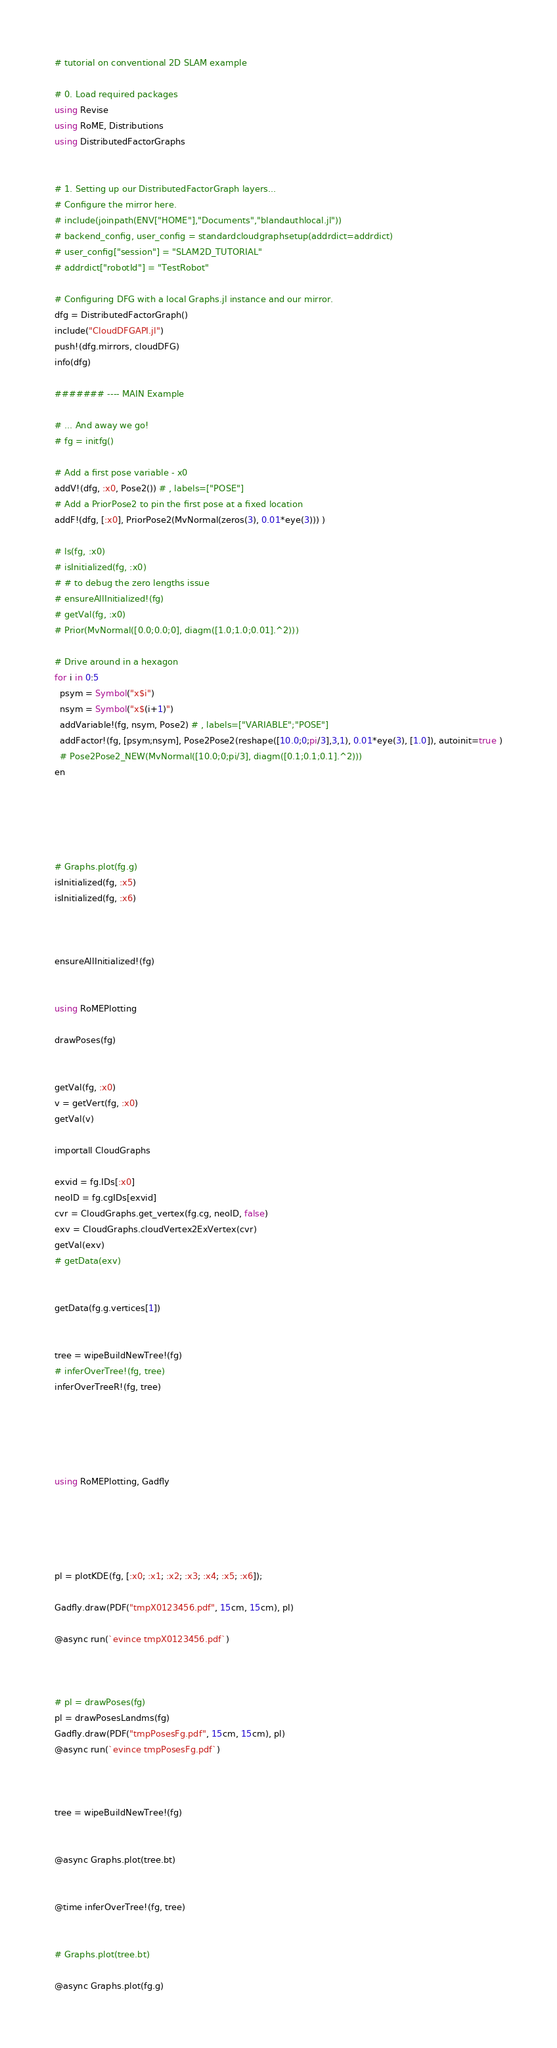Convert code to text. <code><loc_0><loc_0><loc_500><loc_500><_Julia_># tutorial on conventional 2D SLAM example

# 0. Load required packages
using Revise
using RoME, Distributions
using DistributedFactorGraphs


# 1. Setting up our DistributedFactorGraph layers...
# Configure the mirror here.
# include(joinpath(ENV["HOME"],"Documents","blandauthlocal.jl"))
# backend_config, user_config = standardcloudgraphsetup(addrdict=addrdict)
# user_config["session"] = "SLAM2D_TUTORIAL"
# addrdict["robotId"] = "TestRobot"

# Configuring DFG with a local Graphs.jl instance and our mirror.
dfg = DistributedFactorGraph()
include("CloudDFGAPI.jl")
push!(dfg.mirrors, cloudDFG)
info(dfg)

####### ---- MAIN Example

# ... And away we go!
# fg = initfg()

# Add a first pose variable - x0
addV!(dfg, :x0, Pose2()) # , labels=["POSE"]
# Add a PriorPose2 to pin the first pose at a fixed location
addF!(dfg, [:x0], PriorPose2(MvNormal(zeros(3), 0.01*eye(3))) )

# ls(fg, :x0)
# isInitialized(fg, :x0)
# # to debug the zero lengths issue
# ensureAllInitialized!(fg)
# getVal(fg, :x0)
# Prior(MvNormal([0.0;0.0;0], diagm([1.0;1.0;0.01].^2)))

# Drive around in a hexagon
for i in 0:5
  psym = Symbol("x$i")
  nsym = Symbol("x$(i+1)")
  addVariable!(fg, nsym, Pose2) # , labels=["VARIABLE";"POSE"]
  addFactor!(fg, [psym;nsym], Pose2Pose2(reshape([10.0;0;pi/3],3,1), 0.01*eye(3), [1.0]), autoinit=true )
  # Pose2Pose2_NEW(MvNormal([10.0;0;pi/3], diagm([0.1;0.1;0.1].^2)))
en





# Graphs.plot(fg.g)
isInitialized(fg, :x5)
isInitialized(fg, :x6)



ensureAllInitialized!(fg)


using RoMEPlotting

drawPoses(fg)


getVal(fg, :x0)
v = getVert(fg, :x0)
getVal(v)

importall CloudGraphs

exvid = fg.IDs[:x0]
neoID = fg.cgIDs[exvid]
cvr = CloudGraphs.get_vertex(fg.cg, neoID, false)
exv = CloudGraphs.cloudVertex2ExVertex(cvr)
getVal(exv)
# getData(exv)


getData(fg.g.vertices[1])


tree = wipeBuildNewTree!(fg)
# inferOverTree!(fg, tree)
inferOverTreeR!(fg, tree)





using RoMEPlotting, Gadfly





pl = plotKDE(fg, [:x0; :x1; :x2; :x3; :x4; :x5; :x6]);

Gadfly.draw(PDF("tmpX0123456.pdf", 15cm, 15cm), pl)

@async run(`evince tmpX0123456.pdf`)



# pl = drawPoses(fg)
pl = drawPosesLandms(fg)
Gadfly.draw(PDF("tmpPosesFg.pdf", 15cm, 15cm), pl)
@async run(`evince tmpPosesFg.pdf`)



tree = wipeBuildNewTree!(fg)


@async Graphs.plot(tree.bt)


@time inferOverTree!(fg, tree)


# Graphs.plot(tree.bt)

@async Graphs.plot(fg.g)
</code> 